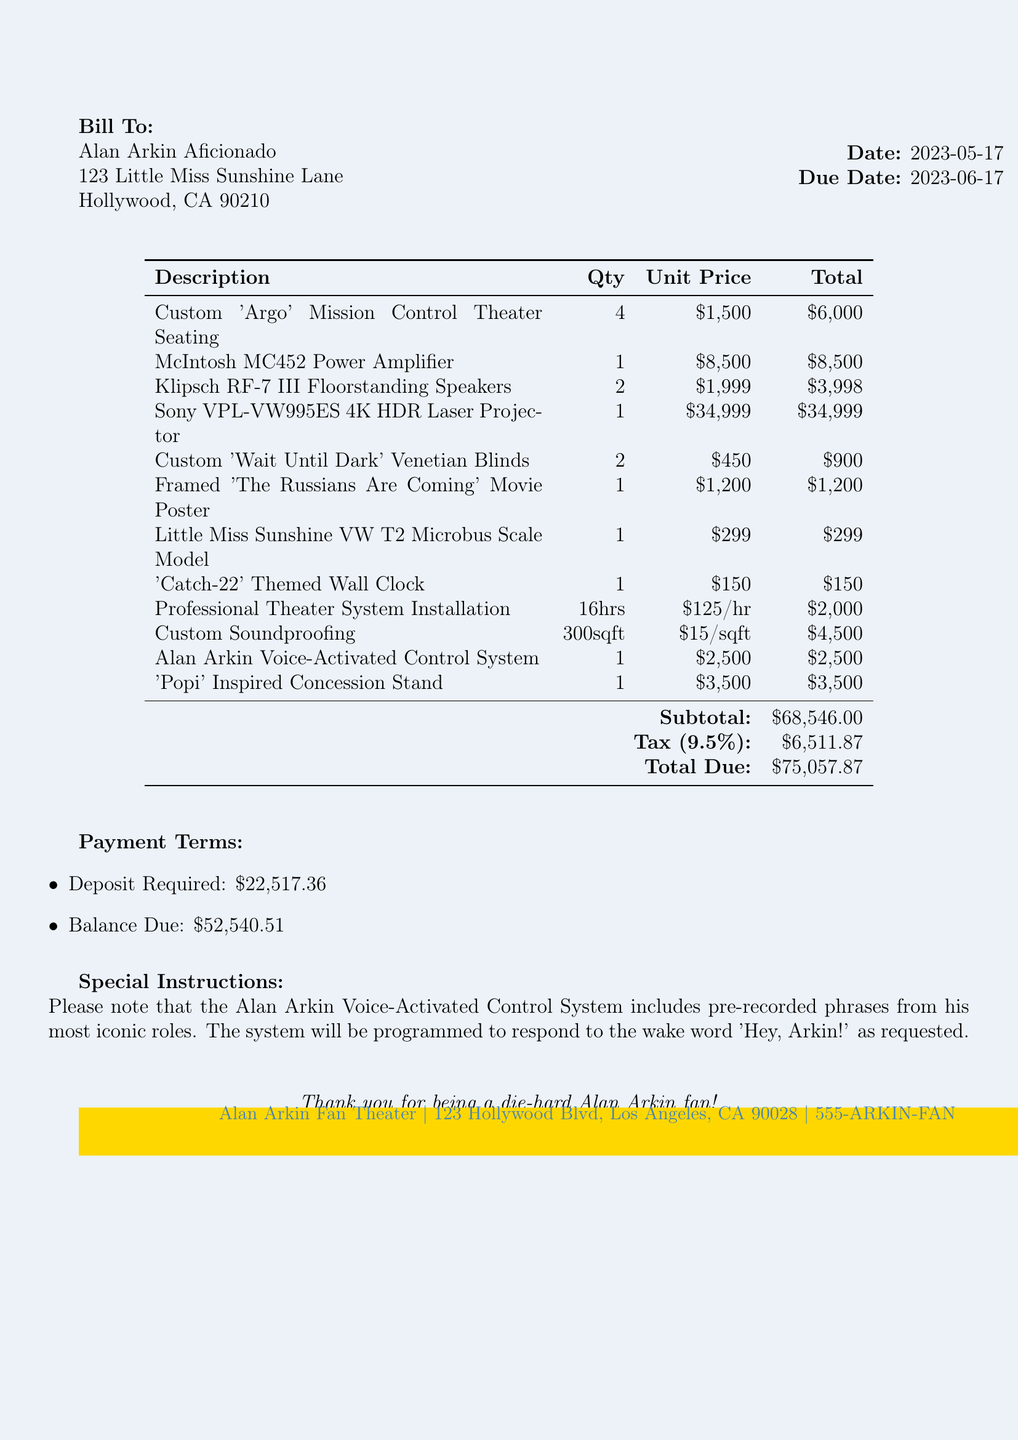What is the invoice number? The invoice number is stated clearly in the document.
Answer: AA2023-0517 What is the due date of the invoice? The due date is mentioned in the invoice details section.
Answer: 2023-06-17 How many units of 'Custom Argo Mission Control Theater Seating' were ordered? The quantity of 'Custom Argo Mission Control Theater Seating' is specified in the theater system components.
Answer: 4 What is the total cost of the Sony VPL-VW995ES 4K HDR Laser Projector? The total cost of the projector is listed under theater system components.
Answer: 34999 What is the subtotal before tax? The subtotal is clearly stated in the payment terms section of the document.
Answer: 68546 How many hours of professional installation services are included? The number of hours for installation services is specified in the installation services section.
Answer: 16 What is the tax rate applied to the invoice? The tax rate is mentioned in the payment terms.
Answer: 9.5% What special feature is included in the Alan Arkin Voice-Activated Control System? The special instruction about the voice-activated control system is provided in the special instructions.
Answer: Pre-recorded phrases from his most iconic roles What is the total amount due upon completion of the invoice? The total amount due is mentioned in the payment terms.
Answer: 75057.87 